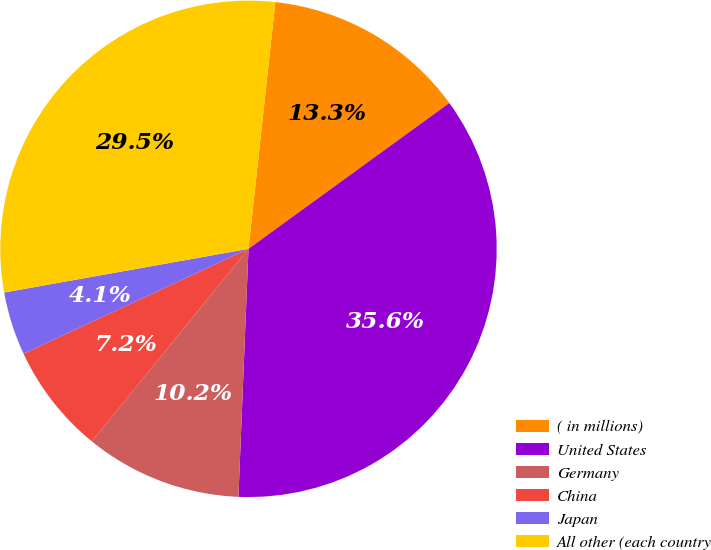<chart> <loc_0><loc_0><loc_500><loc_500><pie_chart><fcel>( in millions)<fcel>United States<fcel>Germany<fcel>China<fcel>Japan<fcel>All other (each country<nl><fcel>13.28%<fcel>35.64%<fcel>10.23%<fcel>7.18%<fcel>4.13%<fcel>29.54%<nl></chart> 